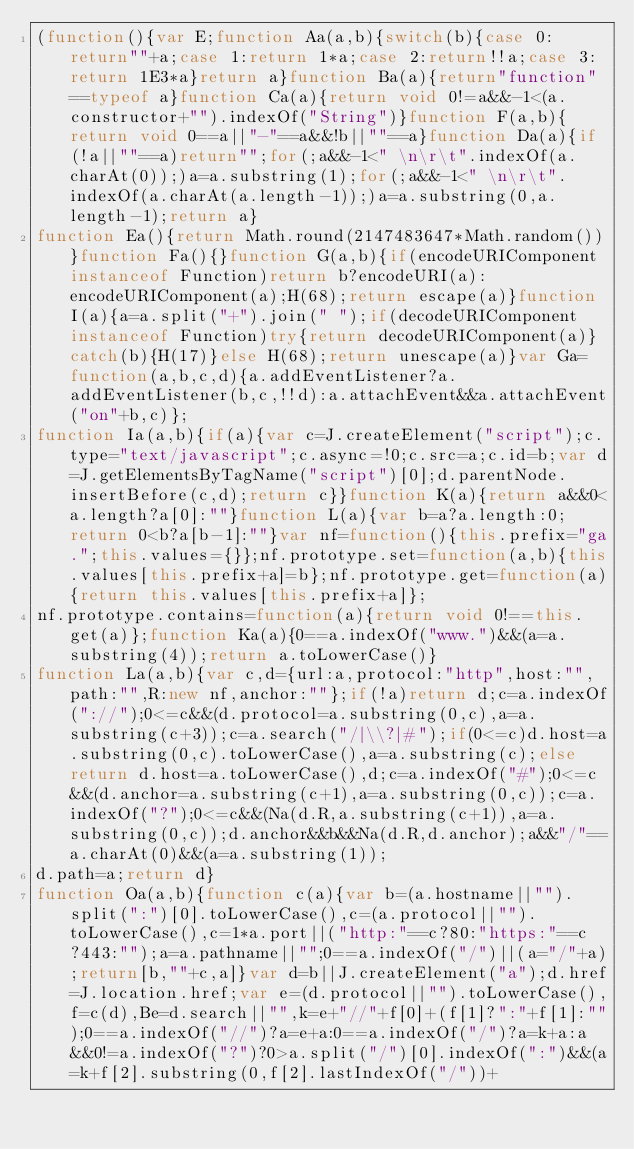Convert code to text. <code><loc_0><loc_0><loc_500><loc_500><_JavaScript_>(function(){var E;function Aa(a,b){switch(b){case 0:return""+a;case 1:return 1*a;case 2:return!!a;case 3:return 1E3*a}return a}function Ba(a){return"function"==typeof a}function Ca(a){return void 0!=a&&-1<(a.constructor+"").indexOf("String")}function F(a,b){return void 0==a||"-"==a&&!b||""==a}function Da(a){if(!a||""==a)return"";for(;a&&-1<" \n\r\t".indexOf(a.charAt(0));)a=a.substring(1);for(;a&&-1<" \n\r\t".indexOf(a.charAt(a.length-1));)a=a.substring(0,a.length-1);return a}
function Ea(){return Math.round(2147483647*Math.random())}function Fa(){}function G(a,b){if(encodeURIComponent instanceof Function)return b?encodeURI(a):encodeURIComponent(a);H(68);return escape(a)}function I(a){a=a.split("+").join(" ");if(decodeURIComponent instanceof Function)try{return decodeURIComponent(a)}catch(b){H(17)}else H(68);return unescape(a)}var Ga=function(a,b,c,d){a.addEventListener?a.addEventListener(b,c,!!d):a.attachEvent&&a.attachEvent("on"+b,c)};
function Ia(a,b){if(a){var c=J.createElement("script");c.type="text/javascript";c.async=!0;c.src=a;c.id=b;var d=J.getElementsByTagName("script")[0];d.parentNode.insertBefore(c,d);return c}}function K(a){return a&&0<a.length?a[0]:""}function L(a){var b=a?a.length:0;return 0<b?a[b-1]:""}var nf=function(){this.prefix="ga.";this.values={}};nf.prototype.set=function(a,b){this.values[this.prefix+a]=b};nf.prototype.get=function(a){return this.values[this.prefix+a]};
nf.prototype.contains=function(a){return void 0!==this.get(a)};function Ka(a){0==a.indexOf("www.")&&(a=a.substring(4));return a.toLowerCase()}
function La(a,b){var c,d={url:a,protocol:"http",host:"",path:"",R:new nf,anchor:""};if(!a)return d;c=a.indexOf("://");0<=c&&(d.protocol=a.substring(0,c),a=a.substring(c+3));c=a.search("/|\\?|#");if(0<=c)d.host=a.substring(0,c).toLowerCase(),a=a.substring(c);else return d.host=a.toLowerCase(),d;c=a.indexOf("#");0<=c&&(d.anchor=a.substring(c+1),a=a.substring(0,c));c=a.indexOf("?");0<=c&&(Na(d.R,a.substring(c+1)),a=a.substring(0,c));d.anchor&&b&&Na(d.R,d.anchor);a&&"/"==a.charAt(0)&&(a=a.substring(1));
d.path=a;return d}
function Oa(a,b){function c(a){var b=(a.hostname||"").split(":")[0].toLowerCase(),c=(a.protocol||"").toLowerCase(),c=1*a.port||("http:"==c?80:"https:"==c?443:"");a=a.pathname||"";0==a.indexOf("/")||(a="/"+a);return[b,""+c,a]}var d=b||J.createElement("a");d.href=J.location.href;var e=(d.protocol||"").toLowerCase(),f=c(d),Be=d.search||"",k=e+"//"+f[0]+(f[1]?":"+f[1]:"");0==a.indexOf("//")?a=e+a:0==a.indexOf("/")?a=k+a:a&&0!=a.indexOf("?")?0>a.split("/")[0].indexOf(":")&&(a=k+f[2].substring(0,f[2].lastIndexOf("/"))+</code> 